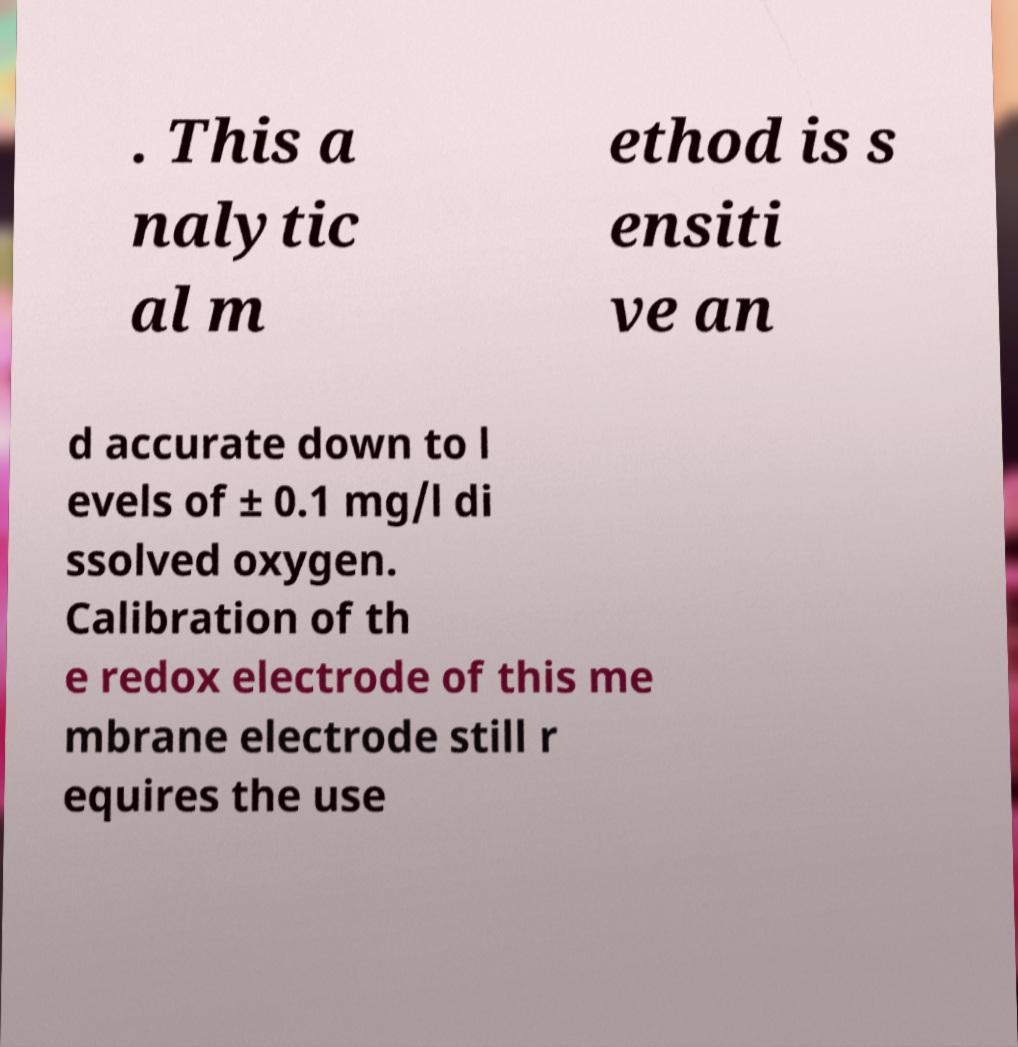Please read and relay the text visible in this image. What does it say? . This a nalytic al m ethod is s ensiti ve an d accurate down to l evels of ± 0.1 mg/l di ssolved oxygen. Calibration of th e redox electrode of this me mbrane electrode still r equires the use 